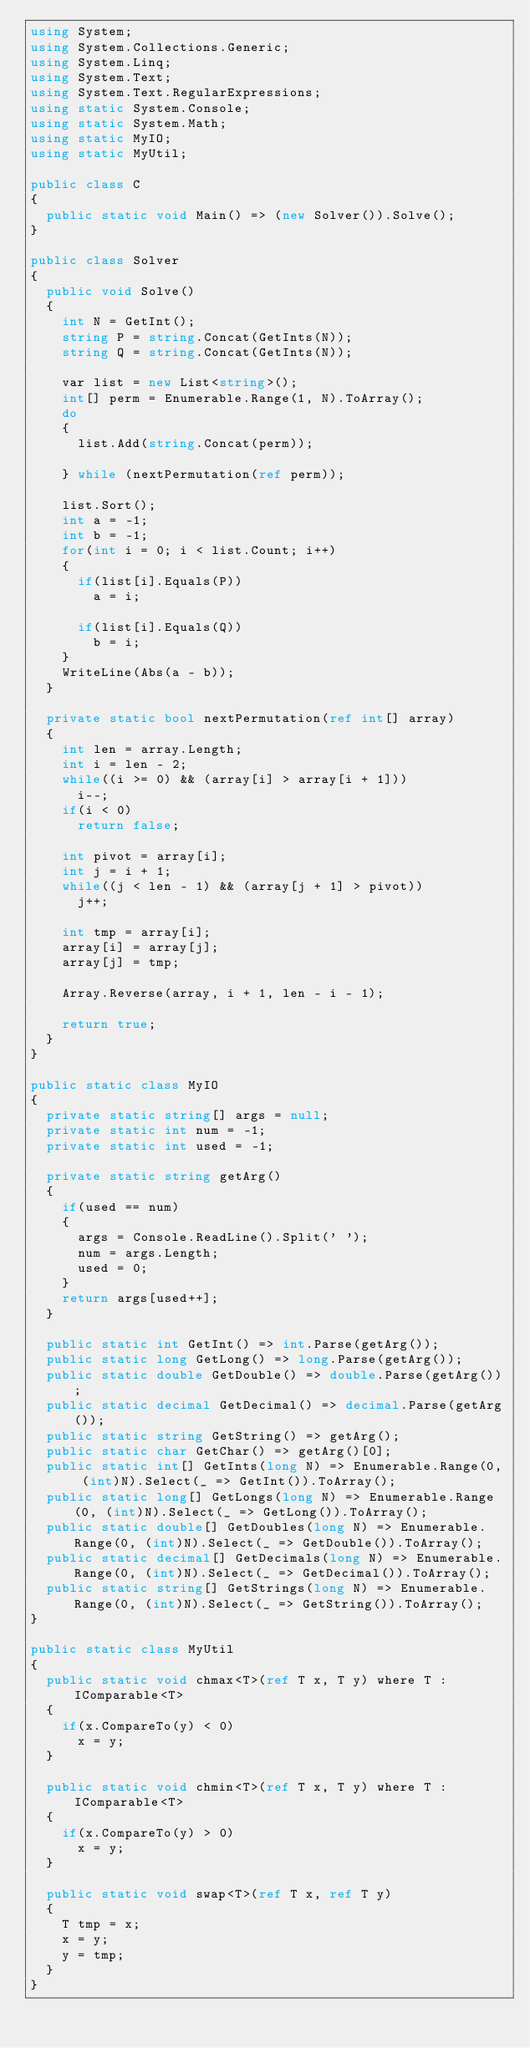<code> <loc_0><loc_0><loc_500><loc_500><_C#_>using System;
using System.Collections.Generic;
using System.Linq;
using System.Text;
using System.Text.RegularExpressions;
using static System.Console;
using static System.Math;
using static MyIO;
using static MyUtil;

public class C
{
	public static void Main() => (new Solver()).Solve();
}

public class Solver
{
	public void Solve()
	{
		int N = GetInt();
		string P = string.Concat(GetInts(N));
		string Q = string.Concat(GetInts(N));

		var list = new List<string>();
		int[] perm = Enumerable.Range(1, N).ToArray();
		do
		{
			list.Add(string.Concat(perm));

		} while (nextPermutation(ref perm));

		list.Sort();
		int a = -1;
		int b = -1;
		for(int i = 0; i < list.Count; i++)
		{
			if(list[i].Equals(P))
				a = i;
		
			if(list[i].Equals(Q))
				b = i;
		}
		WriteLine(Abs(a - b));
	}
	
	private static bool nextPermutation(ref int[] array)
	{
		int len = array.Length;
		int i = len - 2;
		while((i >= 0) && (array[i] > array[i + 1]))
			i--;
		if(i < 0)
			return false;

		int pivot = array[i];
		int j = i + 1;
		while((j < len - 1) && (array[j + 1] > pivot))
			j++;
		
		int tmp = array[i];
		array[i] = array[j];
		array[j] = tmp;
		
		Array.Reverse(array, i + 1, len - i - 1);

		return true;
	}
}

public static class MyIO
{
	private static string[] args = null;
	private static int num = -1;
	private static int used = -1;

	private static string getArg()
	{
		if(used == num)
		{
			args = Console.ReadLine().Split(' ');
			num = args.Length;
			used = 0;
		}
		return args[used++];
	}

	public static int GetInt() => int.Parse(getArg());
	public static long GetLong() => long.Parse(getArg());
	public static double GetDouble() => double.Parse(getArg());
	public static decimal GetDecimal() => decimal.Parse(getArg());
	public static string GetString() => getArg();
	public static char GetChar() => getArg()[0];
	public static int[] GetInts(long N) => Enumerable.Range(0, (int)N).Select(_ => GetInt()).ToArray();
	public static long[] GetLongs(long N) => Enumerable.Range(0, (int)N).Select(_ => GetLong()).ToArray();
	public static double[] GetDoubles(long N) => Enumerable.Range(0, (int)N).Select(_ => GetDouble()).ToArray();
	public static decimal[] GetDecimals(long N) => Enumerable.Range(0, (int)N).Select(_ => GetDecimal()).ToArray();
	public static string[] GetStrings(long N) => Enumerable.Range(0, (int)N).Select(_ => GetString()).ToArray();
}

public static class MyUtil
{
	public static void chmax<T>(ref T x, T y) where T : IComparable<T>
	{
		if(x.CompareTo(y) < 0)
			x = y;
	}

	public static void chmin<T>(ref T x, T y) where T : IComparable<T>
	{
		if(x.CompareTo(y) > 0)
			x = y;
	}

	public static void swap<T>(ref T x, ref T y)
	{
		T tmp = x;
		x = y;
		y = tmp;
	}
}</code> 